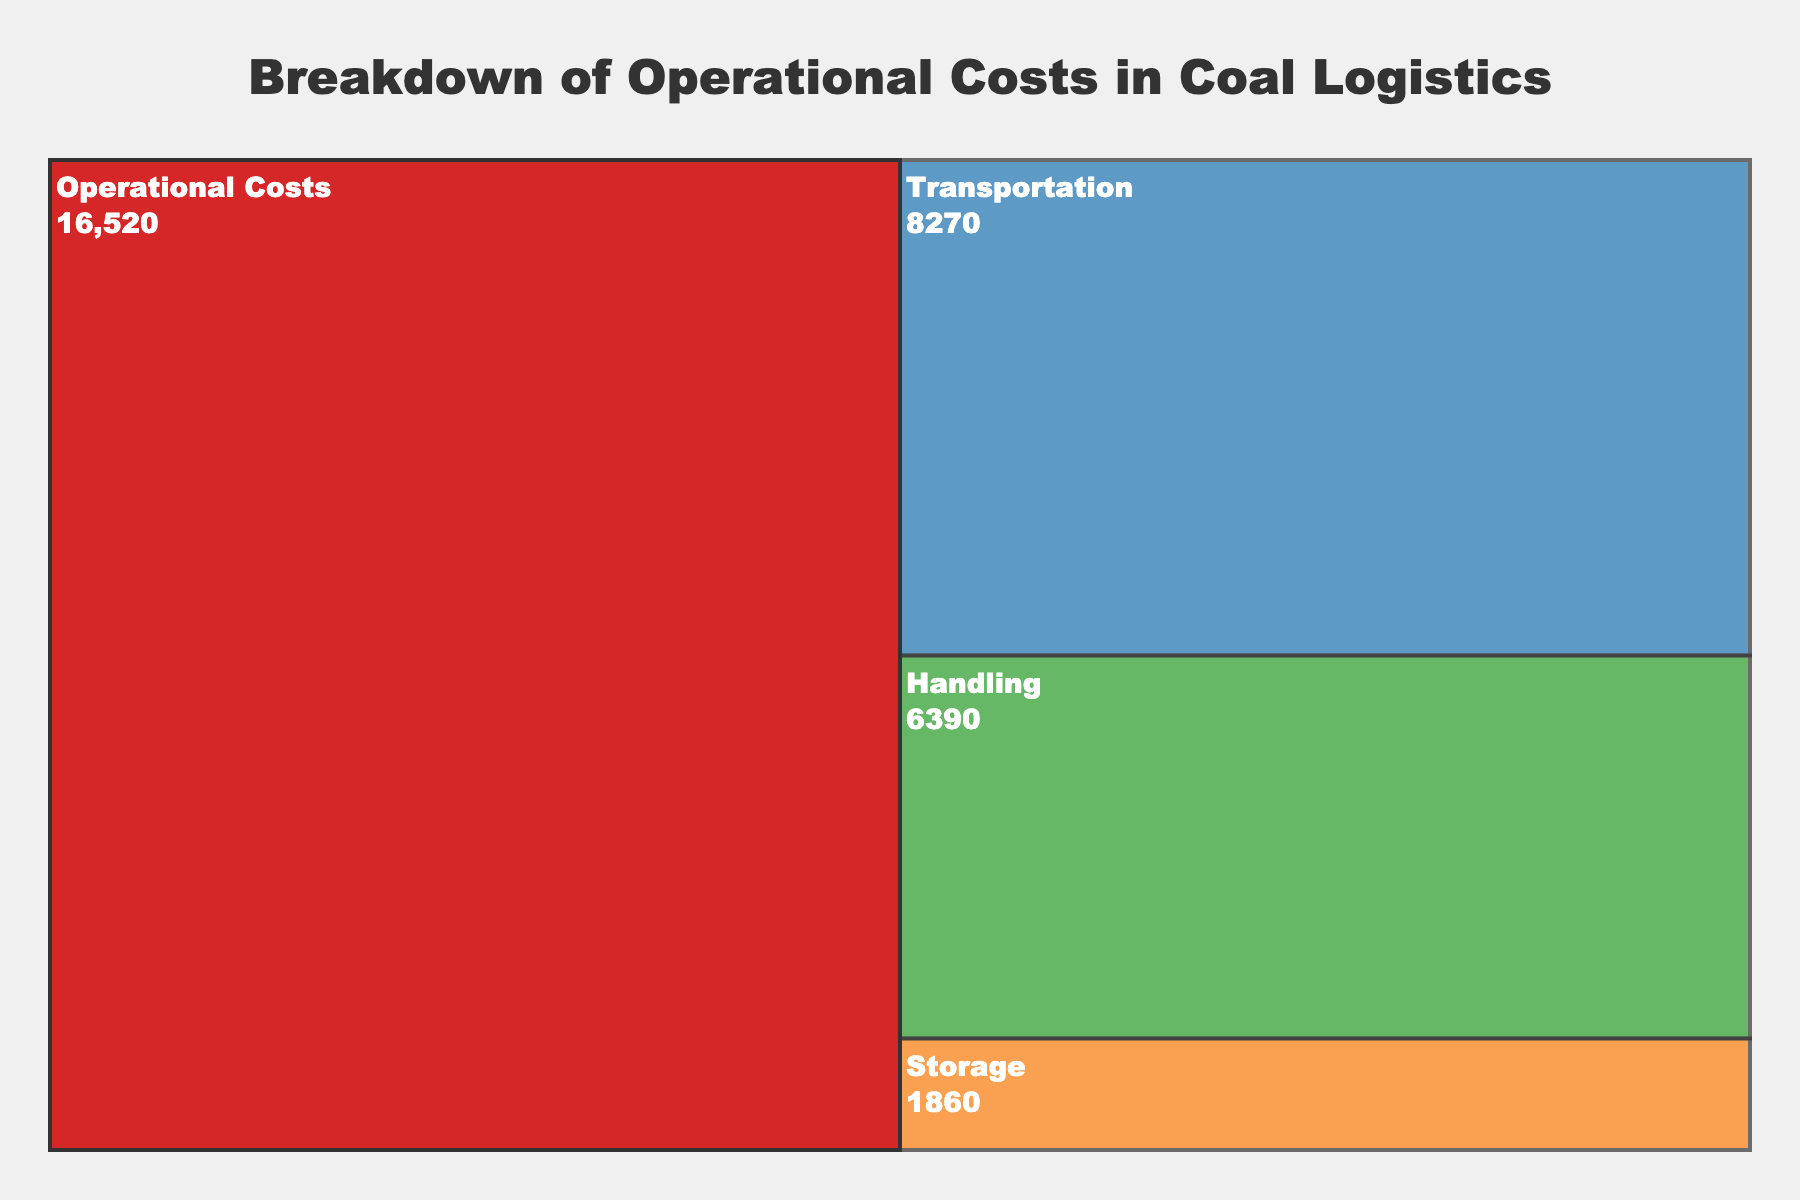what is the total operational cost? The total operational cost can be determined by looking at the root node of the Icicle chart. The root node represents the aggregate of all subcategories. It shows the total value by summing the individual costs of transportation, storage, and handling, which is displayed directly on the chart.
Answer: 21,000 Which subcategory has the highest operational cost? To identify the subcategory with the highest operational cost, inspect the labels and associated values of each subcategory on the Icicle chart. The subcategory with the highest numerical value is the one with the highest cost.
Answer: Storage What is the combined cost of transportation and handling? To calculate the combined cost of transportation and handling, sum the values of these two subcategories. Locate the individual costs for each subcategory on the chart and add them together.
Answer: 11,000 How does the cost of transportation compare to the cost of storage? To compare these costs, look at the numerical values associated with the transportation and storage subcategories. Determine which is larger and, optionally, calculate the difference between them.
Answer: Transportation is less expensive than Storage Which subcategory constitutes the smallest percentage of the total operational cost? Each subcategory's percentage of the total cost can be derived by the proportion of its numerical value to the total value. The smallest value, as a proportion of the whole, will indicate the least significant subcategory.
Answer: Handling 